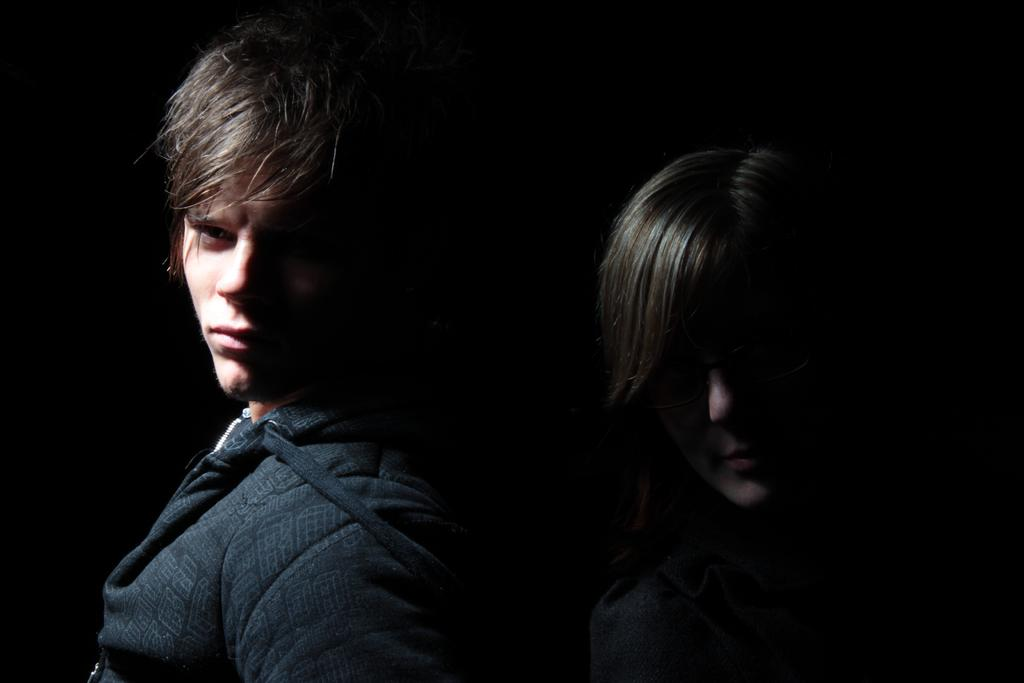How many people are in the image? There are two people in the image. Can you describe the position of the man in the image? The man is on the left side of the image. What is the man wearing in the image? The man is wearing a black jacket. How would you describe the lighting in the image? The image is described as being a little dark. How many pigs are sitting on the seat in the image? There are no pigs or seats present in the image. 